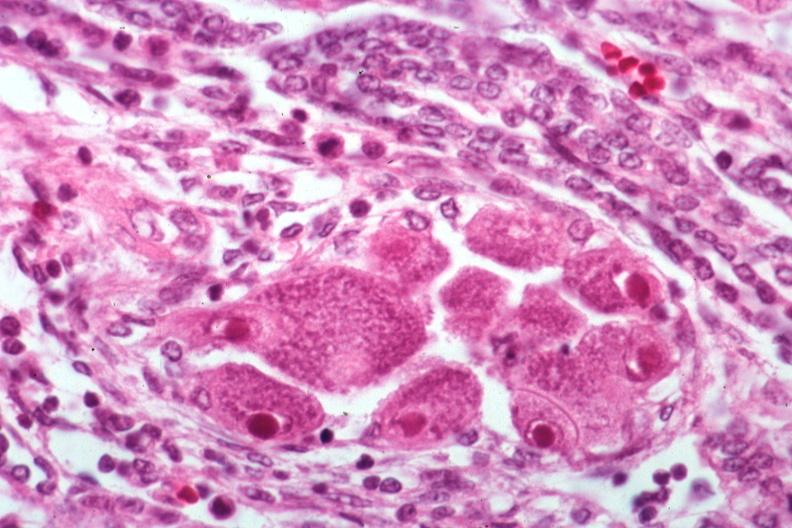what is present?
Answer the question using a single word or phrase. Cytomegalovirus 